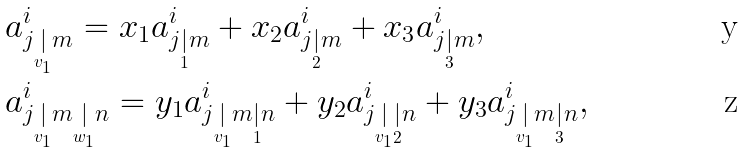Convert formula to latex. <formula><loc_0><loc_0><loc_500><loc_500>& a ^ { i } _ { j \underset { v _ { 1 } } | m } = x _ { 1 } a ^ { i } _ { j \underset { 1 } { | } m } + x _ { 2 } a ^ { i } _ { j \underset { 2 } { | } m } + x _ { 3 } a ^ { i } _ { j \underset { 3 } { | } m } , \\ & a ^ { i } _ { j \underset { v _ { 1 } } | m \underset { w _ { 1 } } | n } = y _ { 1 } a ^ { i } _ { j \underset { v _ { 1 } } | m \underset { 1 } { | } n } + y _ { 2 } a ^ { i } _ { j \underset { v _ { 1 } } | \underset { 2 } { | } n } + y _ { 3 } a ^ { i } _ { j \underset { v _ { 1 } } | m \underset { 3 } { | } n } ,</formula> 